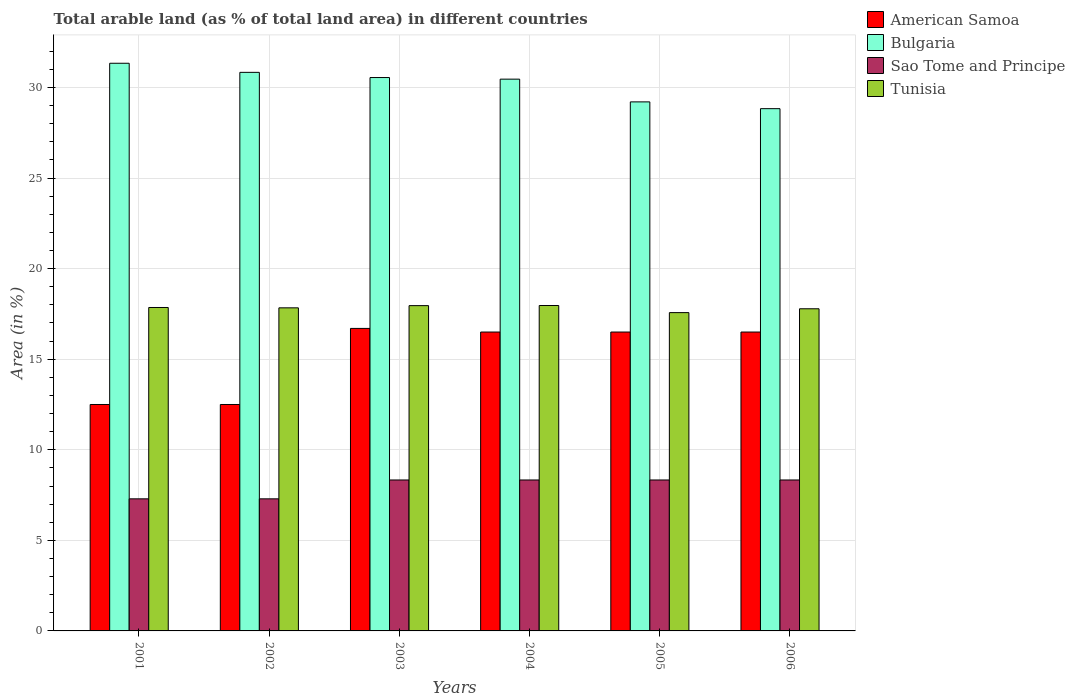How many groups of bars are there?
Your answer should be very brief. 6. What is the percentage of arable land in Sao Tome and Principe in 2005?
Your answer should be very brief. 8.33. Across all years, what is the maximum percentage of arable land in Bulgaria?
Your answer should be very brief. 31.34. What is the total percentage of arable land in Bulgaria in the graph?
Your answer should be compact. 181.23. What is the difference between the percentage of arable land in Bulgaria in 2005 and that in 2006?
Offer a very short reply. 0.37. What is the difference between the percentage of arable land in Tunisia in 2003 and the percentage of arable land in Bulgaria in 2004?
Give a very brief answer. -12.5. What is the average percentage of arable land in Bulgaria per year?
Keep it short and to the point. 30.2. In the year 2003, what is the difference between the percentage of arable land in Bulgaria and percentage of arable land in Tunisia?
Your answer should be compact. 12.59. In how many years, is the percentage of arable land in Bulgaria greater than 27 %?
Give a very brief answer. 6. What is the ratio of the percentage of arable land in American Samoa in 2001 to that in 2005?
Provide a succinct answer. 0.76. Is the difference between the percentage of arable land in Bulgaria in 2003 and 2006 greater than the difference between the percentage of arable land in Tunisia in 2003 and 2006?
Provide a succinct answer. Yes. What is the difference between the highest and the lowest percentage of arable land in Bulgaria?
Your response must be concise. 2.51. In how many years, is the percentage of arable land in Bulgaria greater than the average percentage of arable land in Bulgaria taken over all years?
Offer a terse response. 4. What does the 2nd bar from the left in 2004 represents?
Make the answer very short. Bulgaria. What does the 3rd bar from the right in 2003 represents?
Offer a terse response. Bulgaria. How many bars are there?
Make the answer very short. 24. Are the values on the major ticks of Y-axis written in scientific E-notation?
Your answer should be compact. No. Does the graph contain grids?
Your answer should be compact. Yes. How are the legend labels stacked?
Provide a succinct answer. Vertical. What is the title of the graph?
Offer a very short reply. Total arable land (as % of total land area) in different countries. What is the label or title of the X-axis?
Your response must be concise. Years. What is the label or title of the Y-axis?
Offer a very short reply. Area (in %). What is the Area (in %) of American Samoa in 2001?
Your answer should be very brief. 12.5. What is the Area (in %) in Bulgaria in 2001?
Ensure brevity in your answer.  31.34. What is the Area (in %) of Sao Tome and Principe in 2001?
Offer a terse response. 7.29. What is the Area (in %) of Tunisia in 2001?
Keep it short and to the point. 17.86. What is the Area (in %) in Bulgaria in 2002?
Make the answer very short. 30.84. What is the Area (in %) in Sao Tome and Principe in 2002?
Provide a short and direct response. 7.29. What is the Area (in %) in Tunisia in 2002?
Offer a very short reply. 17.84. What is the Area (in %) of American Samoa in 2003?
Your response must be concise. 16.7. What is the Area (in %) in Bulgaria in 2003?
Ensure brevity in your answer.  30.55. What is the Area (in %) in Sao Tome and Principe in 2003?
Make the answer very short. 8.33. What is the Area (in %) in Tunisia in 2003?
Make the answer very short. 17.96. What is the Area (in %) of Bulgaria in 2004?
Your answer should be very brief. 30.46. What is the Area (in %) of Sao Tome and Principe in 2004?
Offer a very short reply. 8.33. What is the Area (in %) of Tunisia in 2004?
Offer a terse response. 17.96. What is the Area (in %) of Bulgaria in 2005?
Keep it short and to the point. 29.21. What is the Area (in %) in Sao Tome and Principe in 2005?
Provide a succinct answer. 8.33. What is the Area (in %) of Tunisia in 2005?
Ensure brevity in your answer.  17.57. What is the Area (in %) of American Samoa in 2006?
Provide a succinct answer. 16.5. What is the Area (in %) in Bulgaria in 2006?
Your response must be concise. 28.83. What is the Area (in %) in Sao Tome and Principe in 2006?
Your answer should be very brief. 8.33. What is the Area (in %) of Tunisia in 2006?
Offer a terse response. 17.78. Across all years, what is the maximum Area (in %) in Bulgaria?
Make the answer very short. 31.34. Across all years, what is the maximum Area (in %) in Sao Tome and Principe?
Keep it short and to the point. 8.33. Across all years, what is the maximum Area (in %) in Tunisia?
Ensure brevity in your answer.  17.96. Across all years, what is the minimum Area (in %) of American Samoa?
Your answer should be very brief. 12.5. Across all years, what is the minimum Area (in %) of Bulgaria?
Offer a terse response. 28.83. Across all years, what is the minimum Area (in %) in Sao Tome and Principe?
Your response must be concise. 7.29. Across all years, what is the minimum Area (in %) of Tunisia?
Ensure brevity in your answer.  17.57. What is the total Area (in %) of American Samoa in the graph?
Provide a succinct answer. 91.2. What is the total Area (in %) of Bulgaria in the graph?
Your answer should be compact. 181.23. What is the total Area (in %) in Sao Tome and Principe in the graph?
Provide a short and direct response. 47.92. What is the total Area (in %) in Tunisia in the graph?
Offer a terse response. 106.97. What is the difference between the Area (in %) of American Samoa in 2001 and that in 2002?
Offer a terse response. 0. What is the difference between the Area (in %) of Bulgaria in 2001 and that in 2002?
Keep it short and to the point. 0.5. What is the difference between the Area (in %) of Tunisia in 2001 and that in 2002?
Provide a short and direct response. 0.02. What is the difference between the Area (in %) of American Samoa in 2001 and that in 2003?
Ensure brevity in your answer.  -4.2. What is the difference between the Area (in %) in Bulgaria in 2001 and that in 2003?
Provide a short and direct response. 0.79. What is the difference between the Area (in %) in Sao Tome and Principe in 2001 and that in 2003?
Provide a short and direct response. -1.04. What is the difference between the Area (in %) of Tunisia in 2001 and that in 2003?
Make the answer very short. -0.1. What is the difference between the Area (in %) of American Samoa in 2001 and that in 2004?
Give a very brief answer. -4. What is the difference between the Area (in %) of Bulgaria in 2001 and that in 2004?
Provide a succinct answer. 0.88. What is the difference between the Area (in %) in Sao Tome and Principe in 2001 and that in 2004?
Give a very brief answer. -1.04. What is the difference between the Area (in %) of Tunisia in 2001 and that in 2004?
Your answer should be very brief. -0.11. What is the difference between the Area (in %) in Bulgaria in 2001 and that in 2005?
Keep it short and to the point. 2.13. What is the difference between the Area (in %) of Sao Tome and Principe in 2001 and that in 2005?
Your response must be concise. -1.04. What is the difference between the Area (in %) in Tunisia in 2001 and that in 2005?
Ensure brevity in your answer.  0.28. What is the difference between the Area (in %) in Bulgaria in 2001 and that in 2006?
Ensure brevity in your answer.  2.51. What is the difference between the Area (in %) in Sao Tome and Principe in 2001 and that in 2006?
Provide a succinct answer. -1.04. What is the difference between the Area (in %) of Tunisia in 2001 and that in 2006?
Ensure brevity in your answer.  0.07. What is the difference between the Area (in %) in Bulgaria in 2002 and that in 2003?
Your answer should be compact. 0.29. What is the difference between the Area (in %) of Sao Tome and Principe in 2002 and that in 2003?
Offer a terse response. -1.04. What is the difference between the Area (in %) in Tunisia in 2002 and that in 2003?
Your response must be concise. -0.12. What is the difference between the Area (in %) of Bulgaria in 2002 and that in 2004?
Give a very brief answer. 0.37. What is the difference between the Area (in %) of Sao Tome and Principe in 2002 and that in 2004?
Offer a terse response. -1.04. What is the difference between the Area (in %) in Tunisia in 2002 and that in 2004?
Your response must be concise. -0.13. What is the difference between the Area (in %) of American Samoa in 2002 and that in 2005?
Provide a succinct answer. -4. What is the difference between the Area (in %) in Bulgaria in 2002 and that in 2005?
Offer a very short reply. 1.63. What is the difference between the Area (in %) of Sao Tome and Principe in 2002 and that in 2005?
Your response must be concise. -1.04. What is the difference between the Area (in %) of Tunisia in 2002 and that in 2005?
Keep it short and to the point. 0.26. What is the difference between the Area (in %) in Bulgaria in 2002 and that in 2006?
Offer a terse response. 2. What is the difference between the Area (in %) of Sao Tome and Principe in 2002 and that in 2006?
Give a very brief answer. -1.04. What is the difference between the Area (in %) in Tunisia in 2002 and that in 2006?
Provide a succinct answer. 0.05. What is the difference between the Area (in %) in American Samoa in 2003 and that in 2004?
Keep it short and to the point. 0.2. What is the difference between the Area (in %) in Bulgaria in 2003 and that in 2004?
Offer a terse response. 0.09. What is the difference between the Area (in %) of Tunisia in 2003 and that in 2004?
Your answer should be compact. -0.01. What is the difference between the Area (in %) in American Samoa in 2003 and that in 2005?
Offer a terse response. 0.2. What is the difference between the Area (in %) of Bulgaria in 2003 and that in 2005?
Your answer should be compact. 1.34. What is the difference between the Area (in %) of Sao Tome and Principe in 2003 and that in 2005?
Provide a succinct answer. 0. What is the difference between the Area (in %) of Tunisia in 2003 and that in 2005?
Offer a very short reply. 0.39. What is the difference between the Area (in %) of Bulgaria in 2003 and that in 2006?
Offer a very short reply. 1.72. What is the difference between the Area (in %) of Sao Tome and Principe in 2003 and that in 2006?
Provide a short and direct response. 0. What is the difference between the Area (in %) in Tunisia in 2003 and that in 2006?
Provide a short and direct response. 0.17. What is the difference between the Area (in %) in Bulgaria in 2004 and that in 2005?
Offer a terse response. 1.25. What is the difference between the Area (in %) in Sao Tome and Principe in 2004 and that in 2005?
Your answer should be compact. 0. What is the difference between the Area (in %) of Tunisia in 2004 and that in 2005?
Your answer should be very brief. 0.39. What is the difference between the Area (in %) of American Samoa in 2004 and that in 2006?
Provide a succinct answer. 0. What is the difference between the Area (in %) of Bulgaria in 2004 and that in 2006?
Offer a terse response. 1.63. What is the difference between the Area (in %) in Tunisia in 2004 and that in 2006?
Offer a terse response. 0.18. What is the difference between the Area (in %) in American Samoa in 2005 and that in 2006?
Ensure brevity in your answer.  0. What is the difference between the Area (in %) of Bulgaria in 2005 and that in 2006?
Offer a very short reply. 0.37. What is the difference between the Area (in %) of Tunisia in 2005 and that in 2006?
Your answer should be very brief. -0.21. What is the difference between the Area (in %) of American Samoa in 2001 and the Area (in %) of Bulgaria in 2002?
Your response must be concise. -18.34. What is the difference between the Area (in %) in American Samoa in 2001 and the Area (in %) in Sao Tome and Principe in 2002?
Provide a succinct answer. 5.21. What is the difference between the Area (in %) of American Samoa in 2001 and the Area (in %) of Tunisia in 2002?
Ensure brevity in your answer.  -5.34. What is the difference between the Area (in %) of Bulgaria in 2001 and the Area (in %) of Sao Tome and Principe in 2002?
Ensure brevity in your answer.  24.05. What is the difference between the Area (in %) in Bulgaria in 2001 and the Area (in %) in Tunisia in 2002?
Your response must be concise. 13.5. What is the difference between the Area (in %) of Sao Tome and Principe in 2001 and the Area (in %) of Tunisia in 2002?
Offer a very short reply. -10.54. What is the difference between the Area (in %) in American Samoa in 2001 and the Area (in %) in Bulgaria in 2003?
Make the answer very short. -18.05. What is the difference between the Area (in %) of American Samoa in 2001 and the Area (in %) of Sao Tome and Principe in 2003?
Your answer should be compact. 4.17. What is the difference between the Area (in %) in American Samoa in 2001 and the Area (in %) in Tunisia in 2003?
Your answer should be compact. -5.46. What is the difference between the Area (in %) of Bulgaria in 2001 and the Area (in %) of Sao Tome and Principe in 2003?
Offer a very short reply. 23.01. What is the difference between the Area (in %) of Bulgaria in 2001 and the Area (in %) of Tunisia in 2003?
Give a very brief answer. 13.38. What is the difference between the Area (in %) of Sao Tome and Principe in 2001 and the Area (in %) of Tunisia in 2003?
Offer a very short reply. -10.67. What is the difference between the Area (in %) in American Samoa in 2001 and the Area (in %) in Bulgaria in 2004?
Provide a short and direct response. -17.96. What is the difference between the Area (in %) in American Samoa in 2001 and the Area (in %) in Sao Tome and Principe in 2004?
Offer a very short reply. 4.17. What is the difference between the Area (in %) in American Samoa in 2001 and the Area (in %) in Tunisia in 2004?
Keep it short and to the point. -5.46. What is the difference between the Area (in %) of Bulgaria in 2001 and the Area (in %) of Sao Tome and Principe in 2004?
Provide a short and direct response. 23.01. What is the difference between the Area (in %) in Bulgaria in 2001 and the Area (in %) in Tunisia in 2004?
Provide a succinct answer. 13.37. What is the difference between the Area (in %) of Sao Tome and Principe in 2001 and the Area (in %) of Tunisia in 2004?
Your answer should be compact. -10.67. What is the difference between the Area (in %) of American Samoa in 2001 and the Area (in %) of Bulgaria in 2005?
Your answer should be compact. -16.71. What is the difference between the Area (in %) in American Samoa in 2001 and the Area (in %) in Sao Tome and Principe in 2005?
Your answer should be compact. 4.17. What is the difference between the Area (in %) of American Samoa in 2001 and the Area (in %) of Tunisia in 2005?
Provide a succinct answer. -5.07. What is the difference between the Area (in %) in Bulgaria in 2001 and the Area (in %) in Sao Tome and Principe in 2005?
Your answer should be compact. 23.01. What is the difference between the Area (in %) in Bulgaria in 2001 and the Area (in %) in Tunisia in 2005?
Provide a short and direct response. 13.77. What is the difference between the Area (in %) in Sao Tome and Principe in 2001 and the Area (in %) in Tunisia in 2005?
Your response must be concise. -10.28. What is the difference between the Area (in %) in American Samoa in 2001 and the Area (in %) in Bulgaria in 2006?
Offer a very short reply. -16.33. What is the difference between the Area (in %) in American Samoa in 2001 and the Area (in %) in Sao Tome and Principe in 2006?
Offer a very short reply. 4.17. What is the difference between the Area (in %) in American Samoa in 2001 and the Area (in %) in Tunisia in 2006?
Your response must be concise. -5.28. What is the difference between the Area (in %) in Bulgaria in 2001 and the Area (in %) in Sao Tome and Principe in 2006?
Provide a short and direct response. 23.01. What is the difference between the Area (in %) in Bulgaria in 2001 and the Area (in %) in Tunisia in 2006?
Ensure brevity in your answer.  13.55. What is the difference between the Area (in %) of Sao Tome and Principe in 2001 and the Area (in %) of Tunisia in 2006?
Provide a succinct answer. -10.49. What is the difference between the Area (in %) of American Samoa in 2002 and the Area (in %) of Bulgaria in 2003?
Ensure brevity in your answer.  -18.05. What is the difference between the Area (in %) in American Samoa in 2002 and the Area (in %) in Sao Tome and Principe in 2003?
Make the answer very short. 4.17. What is the difference between the Area (in %) in American Samoa in 2002 and the Area (in %) in Tunisia in 2003?
Your answer should be very brief. -5.46. What is the difference between the Area (in %) of Bulgaria in 2002 and the Area (in %) of Sao Tome and Principe in 2003?
Make the answer very short. 22.5. What is the difference between the Area (in %) of Bulgaria in 2002 and the Area (in %) of Tunisia in 2003?
Ensure brevity in your answer.  12.88. What is the difference between the Area (in %) in Sao Tome and Principe in 2002 and the Area (in %) in Tunisia in 2003?
Offer a terse response. -10.67. What is the difference between the Area (in %) in American Samoa in 2002 and the Area (in %) in Bulgaria in 2004?
Your answer should be compact. -17.96. What is the difference between the Area (in %) of American Samoa in 2002 and the Area (in %) of Sao Tome and Principe in 2004?
Offer a very short reply. 4.17. What is the difference between the Area (in %) of American Samoa in 2002 and the Area (in %) of Tunisia in 2004?
Your answer should be compact. -5.46. What is the difference between the Area (in %) of Bulgaria in 2002 and the Area (in %) of Sao Tome and Principe in 2004?
Your answer should be very brief. 22.5. What is the difference between the Area (in %) of Bulgaria in 2002 and the Area (in %) of Tunisia in 2004?
Make the answer very short. 12.87. What is the difference between the Area (in %) of Sao Tome and Principe in 2002 and the Area (in %) of Tunisia in 2004?
Give a very brief answer. -10.67. What is the difference between the Area (in %) of American Samoa in 2002 and the Area (in %) of Bulgaria in 2005?
Make the answer very short. -16.71. What is the difference between the Area (in %) of American Samoa in 2002 and the Area (in %) of Sao Tome and Principe in 2005?
Your answer should be very brief. 4.17. What is the difference between the Area (in %) in American Samoa in 2002 and the Area (in %) in Tunisia in 2005?
Your answer should be compact. -5.07. What is the difference between the Area (in %) in Bulgaria in 2002 and the Area (in %) in Sao Tome and Principe in 2005?
Your answer should be very brief. 22.5. What is the difference between the Area (in %) of Bulgaria in 2002 and the Area (in %) of Tunisia in 2005?
Your answer should be very brief. 13.26. What is the difference between the Area (in %) in Sao Tome and Principe in 2002 and the Area (in %) in Tunisia in 2005?
Provide a short and direct response. -10.28. What is the difference between the Area (in %) in American Samoa in 2002 and the Area (in %) in Bulgaria in 2006?
Offer a very short reply. -16.33. What is the difference between the Area (in %) of American Samoa in 2002 and the Area (in %) of Sao Tome and Principe in 2006?
Make the answer very short. 4.17. What is the difference between the Area (in %) in American Samoa in 2002 and the Area (in %) in Tunisia in 2006?
Keep it short and to the point. -5.28. What is the difference between the Area (in %) of Bulgaria in 2002 and the Area (in %) of Sao Tome and Principe in 2006?
Keep it short and to the point. 22.5. What is the difference between the Area (in %) of Bulgaria in 2002 and the Area (in %) of Tunisia in 2006?
Offer a terse response. 13.05. What is the difference between the Area (in %) in Sao Tome and Principe in 2002 and the Area (in %) in Tunisia in 2006?
Offer a very short reply. -10.49. What is the difference between the Area (in %) in American Samoa in 2003 and the Area (in %) in Bulgaria in 2004?
Offer a terse response. -13.76. What is the difference between the Area (in %) of American Samoa in 2003 and the Area (in %) of Sao Tome and Principe in 2004?
Your answer should be compact. 8.37. What is the difference between the Area (in %) in American Samoa in 2003 and the Area (in %) in Tunisia in 2004?
Offer a terse response. -1.26. What is the difference between the Area (in %) of Bulgaria in 2003 and the Area (in %) of Sao Tome and Principe in 2004?
Provide a succinct answer. 22.22. What is the difference between the Area (in %) of Bulgaria in 2003 and the Area (in %) of Tunisia in 2004?
Your answer should be very brief. 12.59. What is the difference between the Area (in %) of Sao Tome and Principe in 2003 and the Area (in %) of Tunisia in 2004?
Ensure brevity in your answer.  -9.63. What is the difference between the Area (in %) of American Samoa in 2003 and the Area (in %) of Bulgaria in 2005?
Provide a succinct answer. -12.51. What is the difference between the Area (in %) of American Samoa in 2003 and the Area (in %) of Sao Tome and Principe in 2005?
Offer a very short reply. 8.37. What is the difference between the Area (in %) of American Samoa in 2003 and the Area (in %) of Tunisia in 2005?
Provide a short and direct response. -0.87. What is the difference between the Area (in %) of Bulgaria in 2003 and the Area (in %) of Sao Tome and Principe in 2005?
Offer a terse response. 22.22. What is the difference between the Area (in %) in Bulgaria in 2003 and the Area (in %) in Tunisia in 2005?
Offer a very short reply. 12.98. What is the difference between the Area (in %) of Sao Tome and Principe in 2003 and the Area (in %) of Tunisia in 2005?
Make the answer very short. -9.24. What is the difference between the Area (in %) in American Samoa in 2003 and the Area (in %) in Bulgaria in 2006?
Keep it short and to the point. -12.13. What is the difference between the Area (in %) in American Samoa in 2003 and the Area (in %) in Sao Tome and Principe in 2006?
Your answer should be compact. 8.37. What is the difference between the Area (in %) in American Samoa in 2003 and the Area (in %) in Tunisia in 2006?
Make the answer very short. -1.08. What is the difference between the Area (in %) of Bulgaria in 2003 and the Area (in %) of Sao Tome and Principe in 2006?
Give a very brief answer. 22.22. What is the difference between the Area (in %) of Bulgaria in 2003 and the Area (in %) of Tunisia in 2006?
Ensure brevity in your answer.  12.77. What is the difference between the Area (in %) of Sao Tome and Principe in 2003 and the Area (in %) of Tunisia in 2006?
Your response must be concise. -9.45. What is the difference between the Area (in %) of American Samoa in 2004 and the Area (in %) of Bulgaria in 2005?
Keep it short and to the point. -12.71. What is the difference between the Area (in %) in American Samoa in 2004 and the Area (in %) in Sao Tome and Principe in 2005?
Ensure brevity in your answer.  8.17. What is the difference between the Area (in %) in American Samoa in 2004 and the Area (in %) in Tunisia in 2005?
Provide a succinct answer. -1.07. What is the difference between the Area (in %) of Bulgaria in 2004 and the Area (in %) of Sao Tome and Principe in 2005?
Give a very brief answer. 22.13. What is the difference between the Area (in %) in Bulgaria in 2004 and the Area (in %) in Tunisia in 2005?
Offer a very short reply. 12.89. What is the difference between the Area (in %) of Sao Tome and Principe in 2004 and the Area (in %) of Tunisia in 2005?
Your answer should be compact. -9.24. What is the difference between the Area (in %) in American Samoa in 2004 and the Area (in %) in Bulgaria in 2006?
Offer a very short reply. -12.33. What is the difference between the Area (in %) of American Samoa in 2004 and the Area (in %) of Sao Tome and Principe in 2006?
Offer a terse response. 8.17. What is the difference between the Area (in %) of American Samoa in 2004 and the Area (in %) of Tunisia in 2006?
Offer a very short reply. -1.28. What is the difference between the Area (in %) of Bulgaria in 2004 and the Area (in %) of Sao Tome and Principe in 2006?
Give a very brief answer. 22.13. What is the difference between the Area (in %) of Bulgaria in 2004 and the Area (in %) of Tunisia in 2006?
Provide a short and direct response. 12.68. What is the difference between the Area (in %) of Sao Tome and Principe in 2004 and the Area (in %) of Tunisia in 2006?
Make the answer very short. -9.45. What is the difference between the Area (in %) in American Samoa in 2005 and the Area (in %) in Bulgaria in 2006?
Ensure brevity in your answer.  -12.33. What is the difference between the Area (in %) of American Samoa in 2005 and the Area (in %) of Sao Tome and Principe in 2006?
Provide a short and direct response. 8.17. What is the difference between the Area (in %) of American Samoa in 2005 and the Area (in %) of Tunisia in 2006?
Offer a very short reply. -1.28. What is the difference between the Area (in %) in Bulgaria in 2005 and the Area (in %) in Sao Tome and Principe in 2006?
Make the answer very short. 20.87. What is the difference between the Area (in %) in Bulgaria in 2005 and the Area (in %) in Tunisia in 2006?
Make the answer very short. 11.42. What is the difference between the Area (in %) in Sao Tome and Principe in 2005 and the Area (in %) in Tunisia in 2006?
Give a very brief answer. -9.45. What is the average Area (in %) in Bulgaria per year?
Your response must be concise. 30.2. What is the average Area (in %) of Sao Tome and Principe per year?
Your answer should be very brief. 7.99. What is the average Area (in %) of Tunisia per year?
Your response must be concise. 17.83. In the year 2001, what is the difference between the Area (in %) of American Samoa and Area (in %) of Bulgaria?
Ensure brevity in your answer.  -18.84. In the year 2001, what is the difference between the Area (in %) of American Samoa and Area (in %) of Sao Tome and Principe?
Ensure brevity in your answer.  5.21. In the year 2001, what is the difference between the Area (in %) of American Samoa and Area (in %) of Tunisia?
Your response must be concise. -5.36. In the year 2001, what is the difference between the Area (in %) in Bulgaria and Area (in %) in Sao Tome and Principe?
Provide a short and direct response. 24.05. In the year 2001, what is the difference between the Area (in %) of Bulgaria and Area (in %) of Tunisia?
Provide a short and direct response. 13.48. In the year 2001, what is the difference between the Area (in %) of Sao Tome and Principe and Area (in %) of Tunisia?
Your answer should be compact. -10.56. In the year 2002, what is the difference between the Area (in %) in American Samoa and Area (in %) in Bulgaria?
Your answer should be compact. -18.34. In the year 2002, what is the difference between the Area (in %) in American Samoa and Area (in %) in Sao Tome and Principe?
Ensure brevity in your answer.  5.21. In the year 2002, what is the difference between the Area (in %) in American Samoa and Area (in %) in Tunisia?
Provide a short and direct response. -5.34. In the year 2002, what is the difference between the Area (in %) of Bulgaria and Area (in %) of Sao Tome and Principe?
Your answer should be compact. 23.54. In the year 2002, what is the difference between the Area (in %) of Bulgaria and Area (in %) of Tunisia?
Offer a terse response. 13. In the year 2002, what is the difference between the Area (in %) in Sao Tome and Principe and Area (in %) in Tunisia?
Ensure brevity in your answer.  -10.54. In the year 2003, what is the difference between the Area (in %) in American Samoa and Area (in %) in Bulgaria?
Keep it short and to the point. -13.85. In the year 2003, what is the difference between the Area (in %) of American Samoa and Area (in %) of Sao Tome and Principe?
Your response must be concise. 8.37. In the year 2003, what is the difference between the Area (in %) of American Samoa and Area (in %) of Tunisia?
Your answer should be very brief. -1.26. In the year 2003, what is the difference between the Area (in %) in Bulgaria and Area (in %) in Sao Tome and Principe?
Offer a terse response. 22.22. In the year 2003, what is the difference between the Area (in %) in Bulgaria and Area (in %) in Tunisia?
Your response must be concise. 12.59. In the year 2003, what is the difference between the Area (in %) of Sao Tome and Principe and Area (in %) of Tunisia?
Your response must be concise. -9.62. In the year 2004, what is the difference between the Area (in %) in American Samoa and Area (in %) in Bulgaria?
Make the answer very short. -13.96. In the year 2004, what is the difference between the Area (in %) of American Samoa and Area (in %) of Sao Tome and Principe?
Keep it short and to the point. 8.17. In the year 2004, what is the difference between the Area (in %) in American Samoa and Area (in %) in Tunisia?
Make the answer very short. -1.46. In the year 2004, what is the difference between the Area (in %) in Bulgaria and Area (in %) in Sao Tome and Principe?
Your answer should be compact. 22.13. In the year 2004, what is the difference between the Area (in %) in Bulgaria and Area (in %) in Tunisia?
Provide a succinct answer. 12.5. In the year 2004, what is the difference between the Area (in %) in Sao Tome and Principe and Area (in %) in Tunisia?
Offer a very short reply. -9.63. In the year 2005, what is the difference between the Area (in %) of American Samoa and Area (in %) of Bulgaria?
Offer a very short reply. -12.71. In the year 2005, what is the difference between the Area (in %) of American Samoa and Area (in %) of Sao Tome and Principe?
Offer a terse response. 8.17. In the year 2005, what is the difference between the Area (in %) of American Samoa and Area (in %) of Tunisia?
Offer a very short reply. -1.07. In the year 2005, what is the difference between the Area (in %) of Bulgaria and Area (in %) of Sao Tome and Principe?
Offer a very short reply. 20.87. In the year 2005, what is the difference between the Area (in %) of Bulgaria and Area (in %) of Tunisia?
Your response must be concise. 11.63. In the year 2005, what is the difference between the Area (in %) of Sao Tome and Principe and Area (in %) of Tunisia?
Make the answer very short. -9.24. In the year 2006, what is the difference between the Area (in %) of American Samoa and Area (in %) of Bulgaria?
Provide a short and direct response. -12.33. In the year 2006, what is the difference between the Area (in %) in American Samoa and Area (in %) in Sao Tome and Principe?
Provide a succinct answer. 8.17. In the year 2006, what is the difference between the Area (in %) of American Samoa and Area (in %) of Tunisia?
Offer a very short reply. -1.28. In the year 2006, what is the difference between the Area (in %) of Bulgaria and Area (in %) of Sao Tome and Principe?
Your answer should be compact. 20.5. In the year 2006, what is the difference between the Area (in %) of Bulgaria and Area (in %) of Tunisia?
Offer a very short reply. 11.05. In the year 2006, what is the difference between the Area (in %) of Sao Tome and Principe and Area (in %) of Tunisia?
Your response must be concise. -9.45. What is the ratio of the Area (in %) in American Samoa in 2001 to that in 2002?
Offer a terse response. 1. What is the ratio of the Area (in %) of Bulgaria in 2001 to that in 2002?
Your answer should be compact. 1.02. What is the ratio of the Area (in %) of American Samoa in 2001 to that in 2003?
Provide a succinct answer. 0.75. What is the ratio of the Area (in %) of Bulgaria in 2001 to that in 2003?
Your answer should be compact. 1.03. What is the ratio of the Area (in %) in American Samoa in 2001 to that in 2004?
Provide a succinct answer. 0.76. What is the ratio of the Area (in %) of Bulgaria in 2001 to that in 2004?
Your answer should be compact. 1.03. What is the ratio of the Area (in %) in Sao Tome and Principe in 2001 to that in 2004?
Give a very brief answer. 0.88. What is the ratio of the Area (in %) in American Samoa in 2001 to that in 2005?
Make the answer very short. 0.76. What is the ratio of the Area (in %) of Bulgaria in 2001 to that in 2005?
Your answer should be compact. 1.07. What is the ratio of the Area (in %) of Tunisia in 2001 to that in 2005?
Keep it short and to the point. 1.02. What is the ratio of the Area (in %) in American Samoa in 2001 to that in 2006?
Make the answer very short. 0.76. What is the ratio of the Area (in %) in Bulgaria in 2001 to that in 2006?
Keep it short and to the point. 1.09. What is the ratio of the Area (in %) of American Samoa in 2002 to that in 2003?
Your response must be concise. 0.75. What is the ratio of the Area (in %) in Bulgaria in 2002 to that in 2003?
Make the answer very short. 1.01. What is the ratio of the Area (in %) of Sao Tome and Principe in 2002 to that in 2003?
Make the answer very short. 0.88. What is the ratio of the Area (in %) of American Samoa in 2002 to that in 2004?
Ensure brevity in your answer.  0.76. What is the ratio of the Area (in %) of Bulgaria in 2002 to that in 2004?
Offer a very short reply. 1.01. What is the ratio of the Area (in %) of Tunisia in 2002 to that in 2004?
Provide a succinct answer. 0.99. What is the ratio of the Area (in %) in American Samoa in 2002 to that in 2005?
Give a very brief answer. 0.76. What is the ratio of the Area (in %) in Bulgaria in 2002 to that in 2005?
Your answer should be compact. 1.06. What is the ratio of the Area (in %) of Sao Tome and Principe in 2002 to that in 2005?
Offer a very short reply. 0.88. What is the ratio of the Area (in %) in Tunisia in 2002 to that in 2005?
Give a very brief answer. 1.01. What is the ratio of the Area (in %) in American Samoa in 2002 to that in 2006?
Ensure brevity in your answer.  0.76. What is the ratio of the Area (in %) in Bulgaria in 2002 to that in 2006?
Your response must be concise. 1.07. What is the ratio of the Area (in %) in Tunisia in 2002 to that in 2006?
Offer a very short reply. 1. What is the ratio of the Area (in %) of American Samoa in 2003 to that in 2004?
Offer a very short reply. 1.01. What is the ratio of the Area (in %) of American Samoa in 2003 to that in 2005?
Offer a terse response. 1.01. What is the ratio of the Area (in %) of Bulgaria in 2003 to that in 2005?
Keep it short and to the point. 1.05. What is the ratio of the Area (in %) in American Samoa in 2003 to that in 2006?
Give a very brief answer. 1.01. What is the ratio of the Area (in %) of Bulgaria in 2003 to that in 2006?
Your response must be concise. 1.06. What is the ratio of the Area (in %) of Tunisia in 2003 to that in 2006?
Your answer should be compact. 1.01. What is the ratio of the Area (in %) of Bulgaria in 2004 to that in 2005?
Your response must be concise. 1.04. What is the ratio of the Area (in %) in Sao Tome and Principe in 2004 to that in 2005?
Provide a succinct answer. 1. What is the ratio of the Area (in %) in Tunisia in 2004 to that in 2005?
Keep it short and to the point. 1.02. What is the ratio of the Area (in %) in American Samoa in 2004 to that in 2006?
Offer a terse response. 1. What is the ratio of the Area (in %) in Bulgaria in 2004 to that in 2006?
Make the answer very short. 1.06. What is the ratio of the Area (in %) of Sao Tome and Principe in 2004 to that in 2006?
Keep it short and to the point. 1. What is the ratio of the Area (in %) of Tunisia in 2004 to that in 2006?
Your answer should be very brief. 1.01. What is the ratio of the Area (in %) in Bulgaria in 2005 to that in 2006?
Make the answer very short. 1.01. What is the difference between the highest and the second highest Area (in %) of Bulgaria?
Keep it short and to the point. 0.5. What is the difference between the highest and the second highest Area (in %) of Sao Tome and Principe?
Offer a terse response. 0. What is the difference between the highest and the second highest Area (in %) of Tunisia?
Offer a terse response. 0.01. What is the difference between the highest and the lowest Area (in %) in American Samoa?
Provide a succinct answer. 4.2. What is the difference between the highest and the lowest Area (in %) in Bulgaria?
Make the answer very short. 2.51. What is the difference between the highest and the lowest Area (in %) in Sao Tome and Principe?
Make the answer very short. 1.04. What is the difference between the highest and the lowest Area (in %) of Tunisia?
Give a very brief answer. 0.39. 